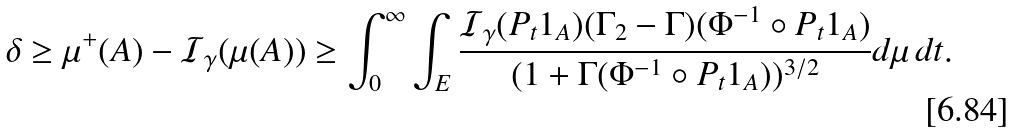Convert formula to latex. <formula><loc_0><loc_0><loc_500><loc_500>\delta \geq \mu ^ { + } ( A ) - \mathcal { I } _ { \gamma } ( \mu ( A ) ) \geq \int _ { 0 } ^ { \infty } \int _ { E } \frac { \mathcal { I } _ { \gamma } ( P _ { t } 1 _ { A } ) ( \Gamma _ { 2 } - \Gamma ) ( \Phi ^ { - 1 } \circ P _ { t } 1 _ { A } ) } { ( 1 + \Gamma ( \Phi ^ { - 1 } \circ P _ { t } 1 _ { A } ) ) ^ { 3 / 2 } } d \mu \, d t .</formula> 